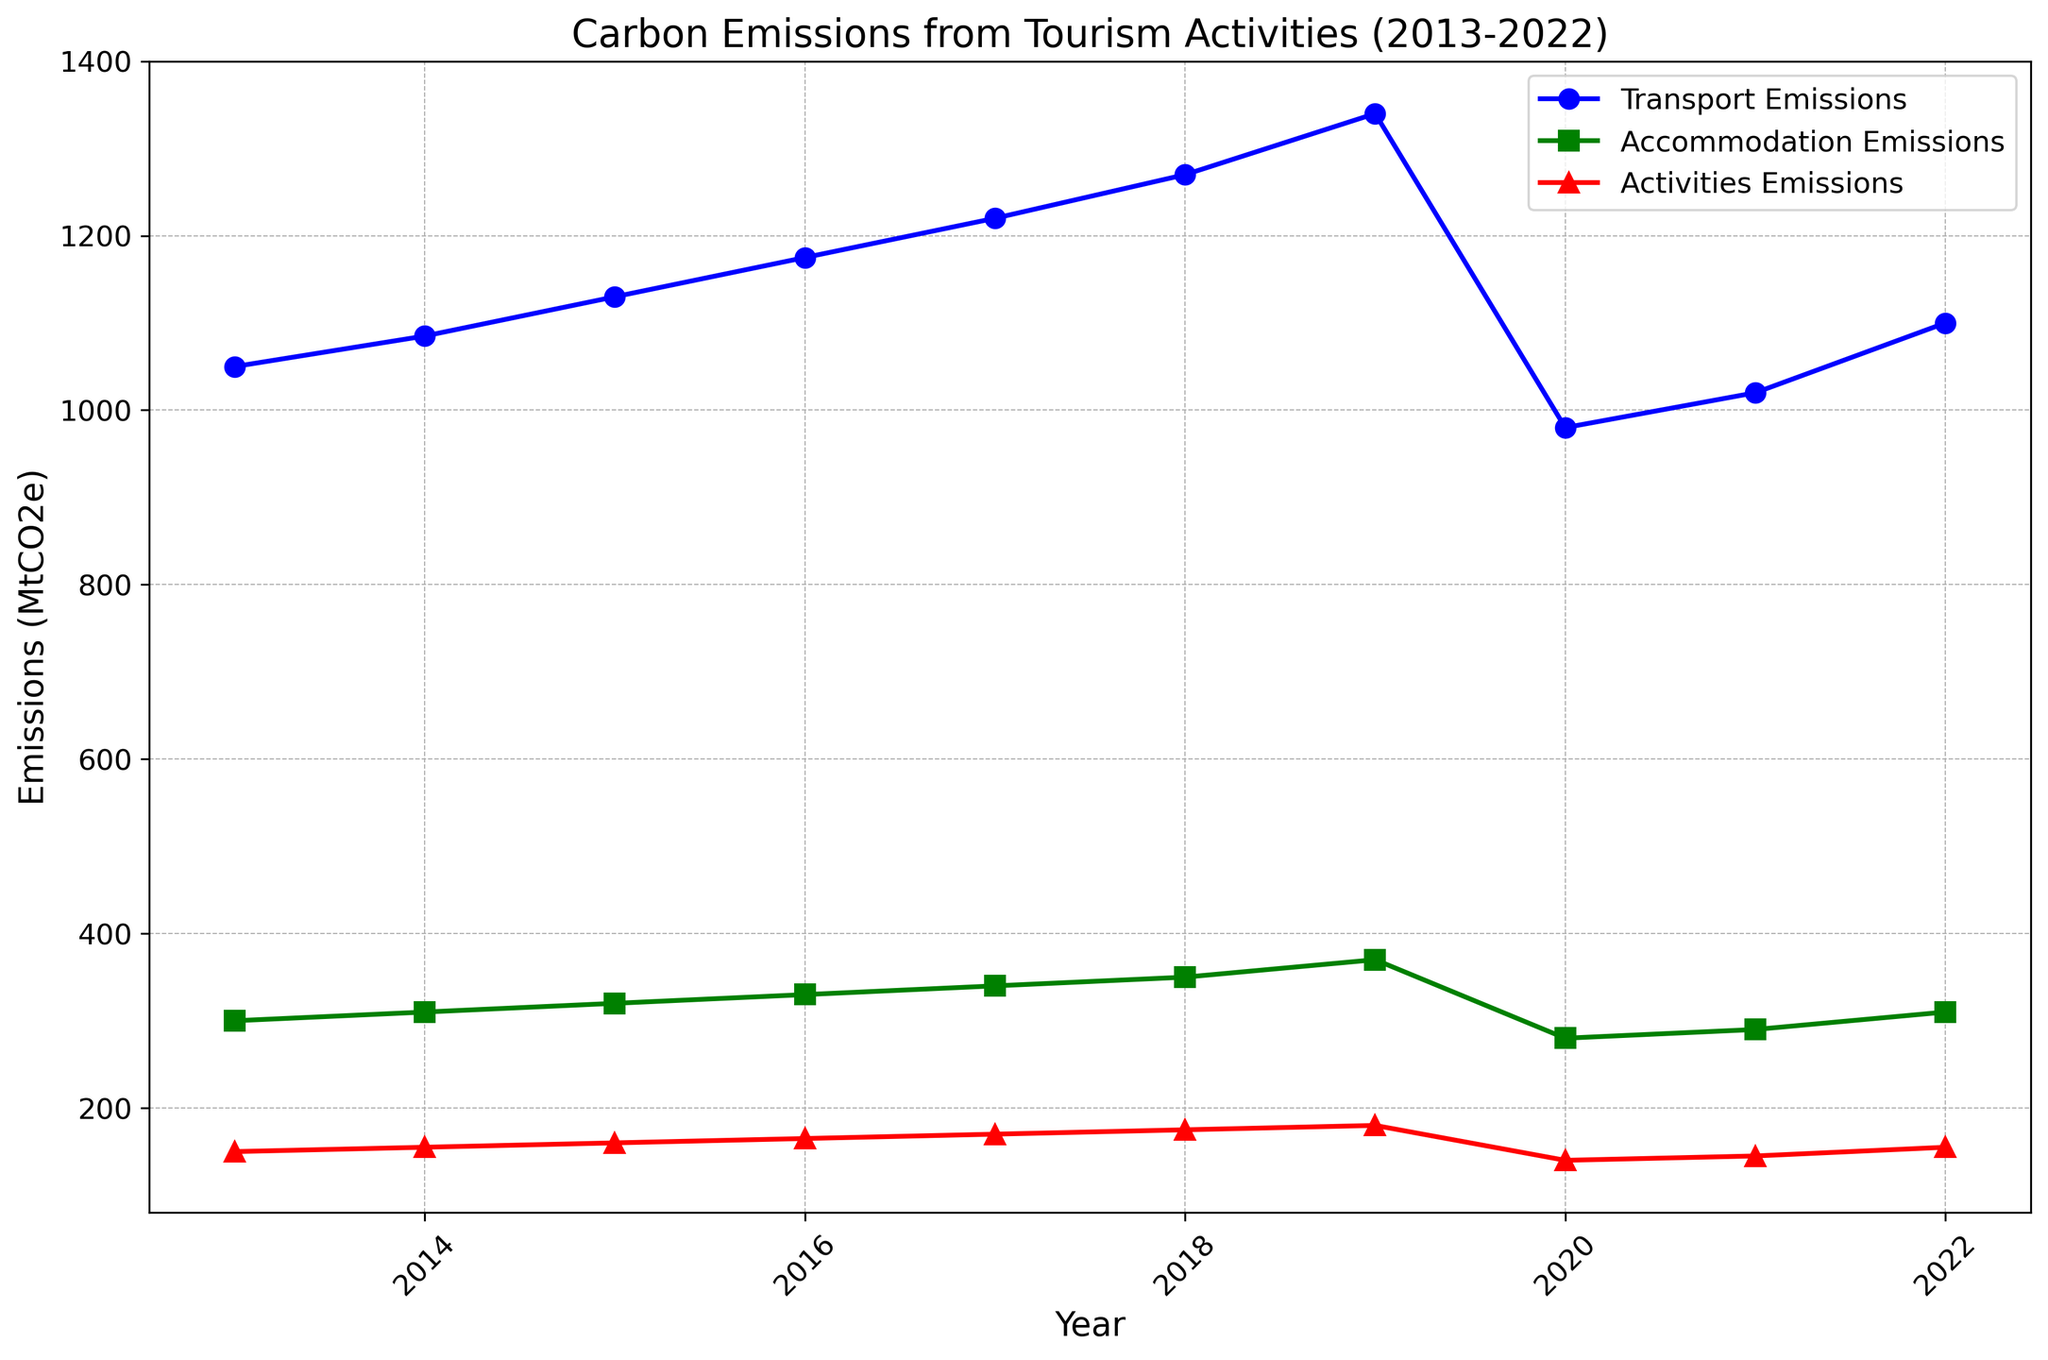Which year had the highest transport emissions? From the chart, the transport emissions line peaks in 2019, indicating that the highest transport emissions occurred that year.
Answer: 2019 How did accommodation emissions change from 2019 to 2020? The chart shows a drop in the accommodation emissions line between 2019 and 2020, specifically from 370 MtCO2e to 280 MtCO2e.
Answer: Decreased What is the difference in transport emissions between 2013 and 2022? Transport emissions were 1050 MtCO2e in 2013 and rose to 1100 MtCO2e in 2022. The difference is calculated as 1100 - 1050.
Answer: 50 MtCO2e During which period did activities emissions remain constant, excluding small fluctuations? The line representing activities emissions stays quite stable from 2020 to 2021, both being very close in value at 140 MtCO2e and 145 MtCO2e respectively.
Answer: 2020-2021 Which category of emissions had the smallest increase over the decade? Comparing the values from 2013 to 2022 for each category: Transport (from 1050 to 1100, increase by 50), Accommodation (from 300 to 310, increase by 10), and Activities (from 150 to 155, increase by 5), Activities emissions had the smallest increase.
Answer: Activities emissions What was the percentage drop in transport emissions from 2019 to 2020? Transport emissions dropped from 1340 MtCO2e in 2019 to 980 MtCO2e in 2020. The percentage drop is calculated as ((1340 - 980) / 1340) * 100. Step-by-step: 1340 - 980 = 360; then 360 / 1340 ≈ 0.2687; finally, 0.2687 * 100 ≈ 26.87%.
Answer: ~26.87% How do accommodation emissions in 2022 compare to those in 2018? In 2022, the accommodation emissions are 310 MtCO2e, and in 2018, they were 350 MtCO2e. Therefore, the accommodation emissions in 2022 are lower than those in 2018.
Answer: Lower Between which consecutive years did transport emissions decrease? Observing the transport emissions line, the only decrease is from 2019 to 2020, where it falls from 1340 MtCO2e to 980 MtCO2e.
Answer: 2019-2020 